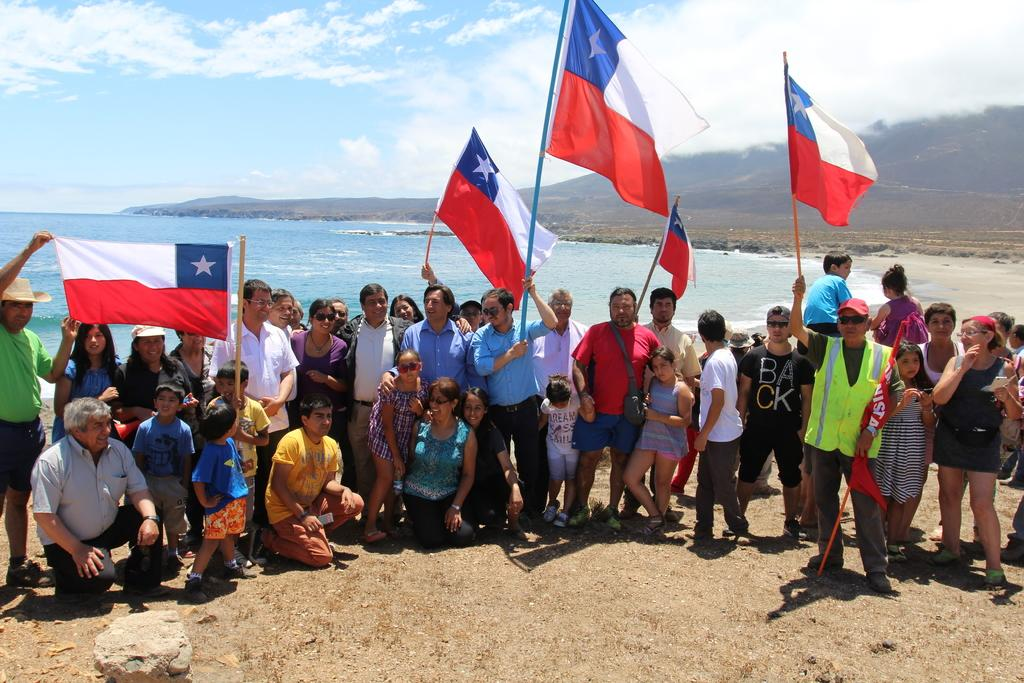How many people are in the image? There is a group of people in the image, but the exact number is not specified. What are the people in the image doing? Some people are standing, while others are sitting. What is the person holding in the image? A person is holding a flag. What can be seen in the distance in the image? There are hills visible in the background of the image. What color is the tiger's sweater in the image? There is no tiger or sweater present in the image. How many quarters are visible on the ground in the image? There are no quarters visible on the ground in the image. 